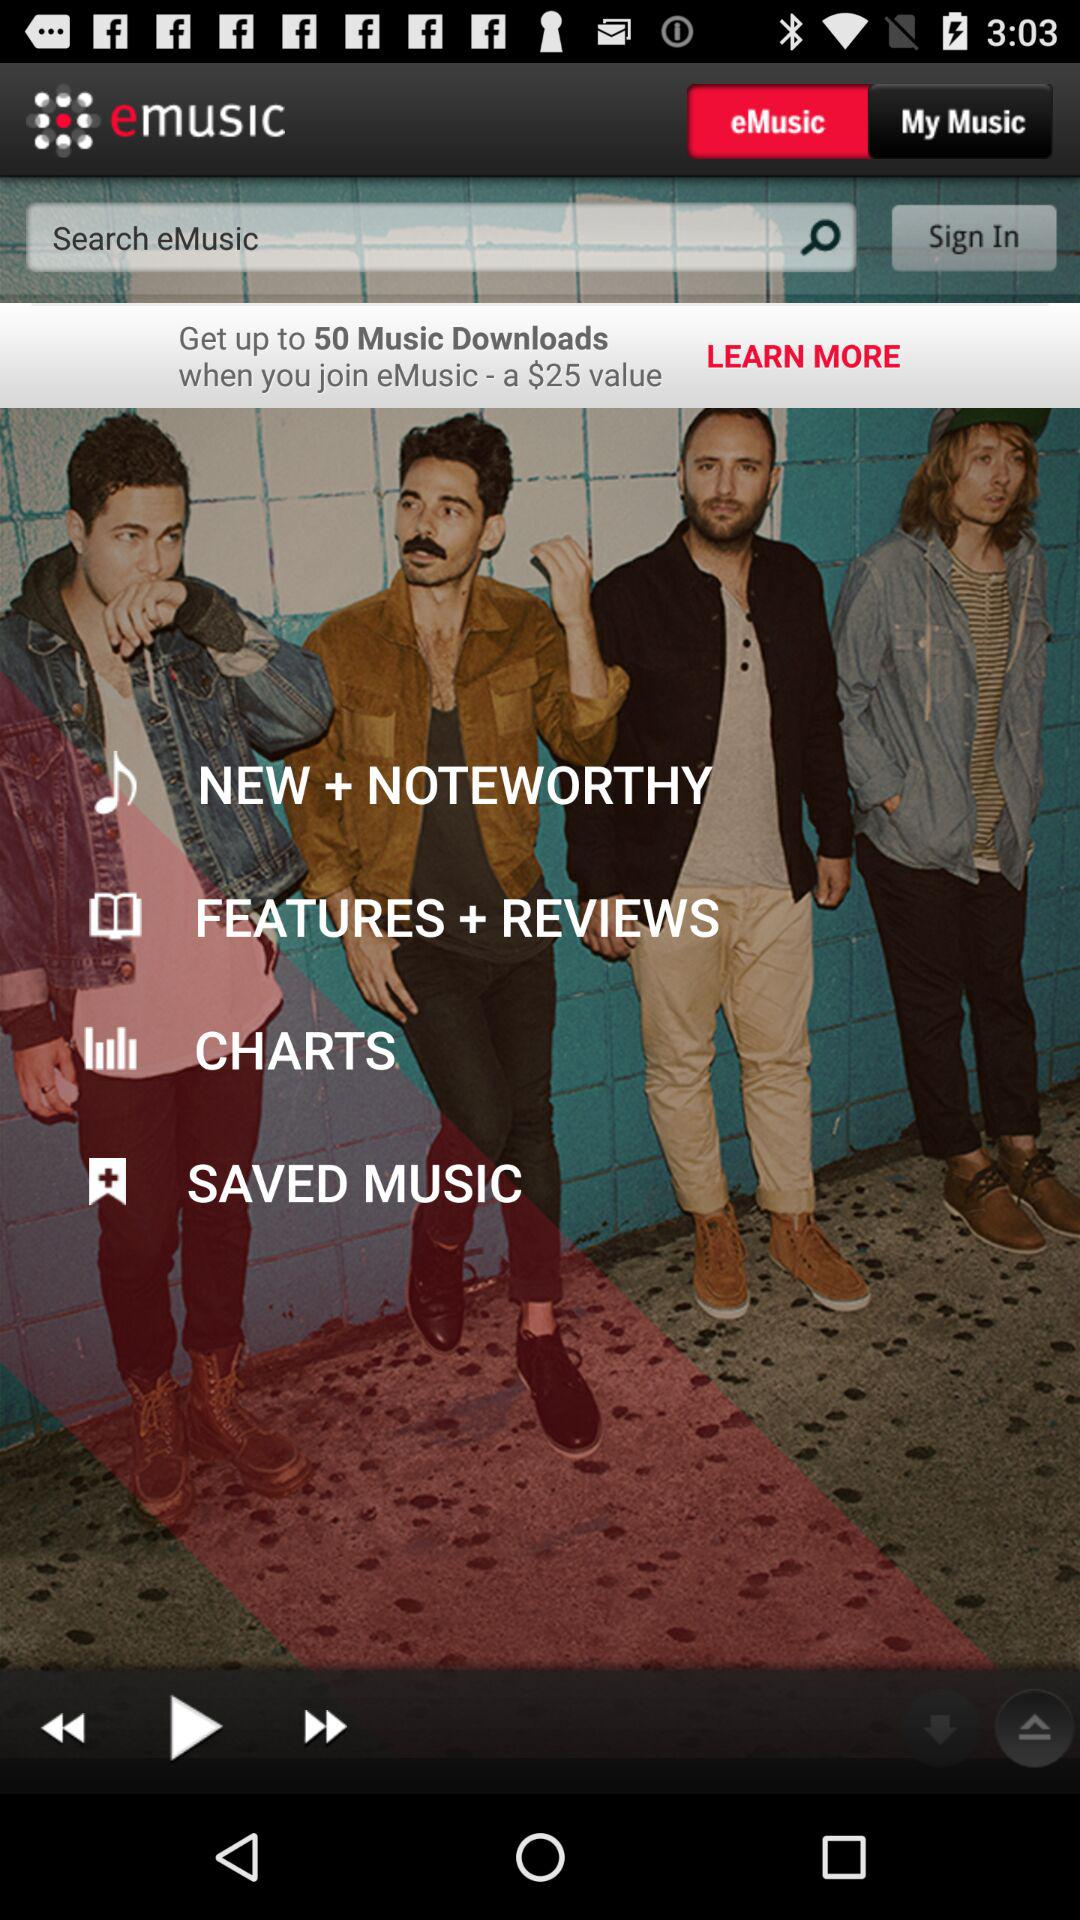What is the name of the application? The name of the application is "emusic". 